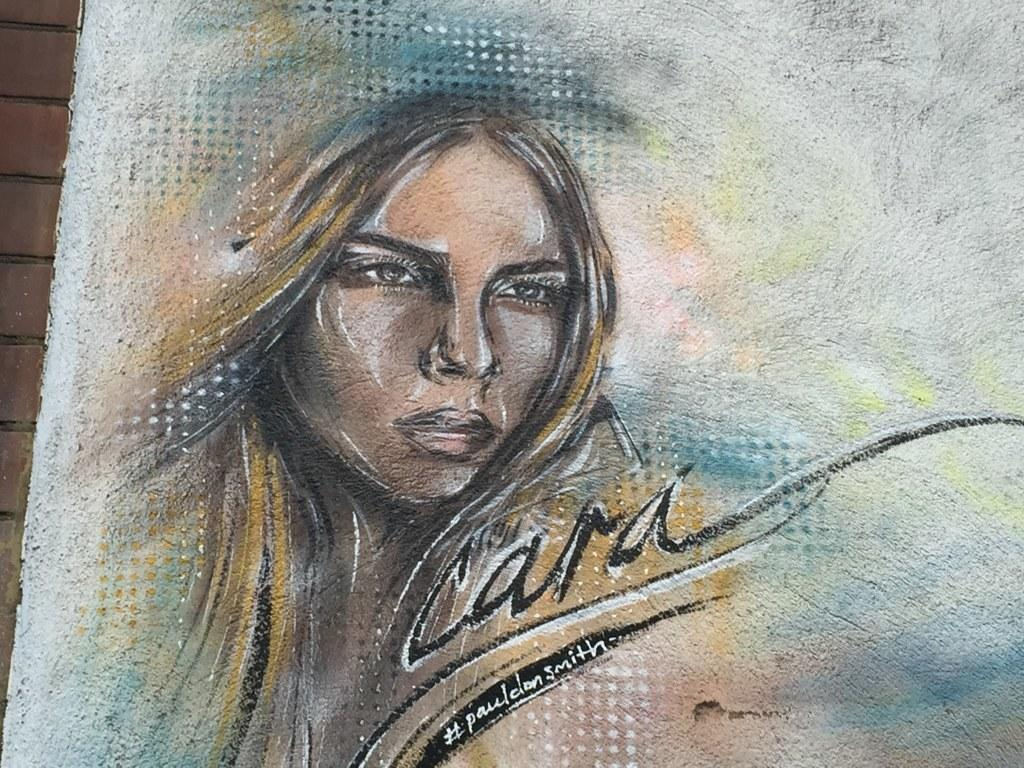What is depicted in the painting in the image? There is a painting of a woman in the image. What else can be seen on the painting besides the woman? There is text on the painting. What is behind the painting in the image? There is a wall behind the painting. What type of leather is used to create the hen in the image? There is no hen or leather present in the image; it features a painting of a woman with text on it. 